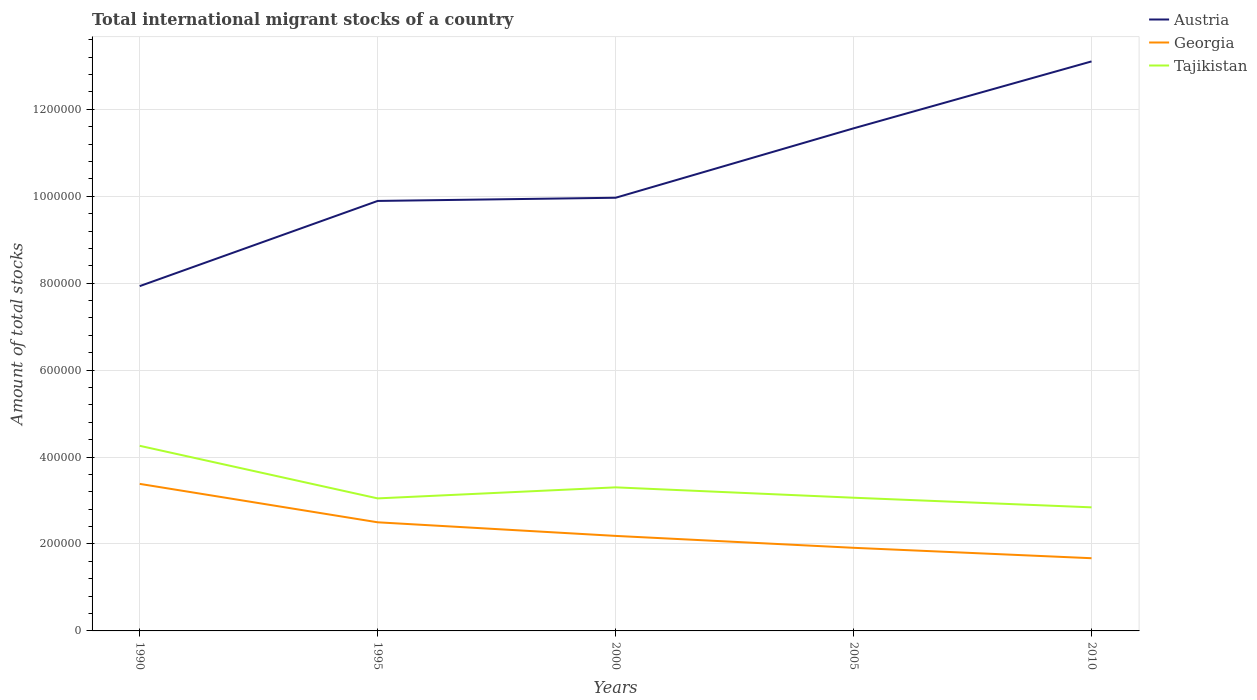Does the line corresponding to Georgia intersect with the line corresponding to Tajikistan?
Provide a short and direct response. No. Is the number of lines equal to the number of legend labels?
Offer a very short reply. Yes. Across all years, what is the maximum amount of total stocks in in Austria?
Keep it short and to the point. 7.93e+05. In which year was the amount of total stocks in in Tajikistan maximum?
Provide a short and direct response. 2010. What is the total amount of total stocks in in Tajikistan in the graph?
Keep it short and to the point. 2.06e+04. What is the difference between the highest and the second highest amount of total stocks in in Georgia?
Give a very brief answer. 1.71e+05. How many lines are there?
Provide a succinct answer. 3. What is the difference between two consecutive major ticks on the Y-axis?
Provide a short and direct response. 2.00e+05. Does the graph contain any zero values?
Provide a short and direct response. No. Where does the legend appear in the graph?
Give a very brief answer. Top right. How are the legend labels stacked?
Your answer should be very brief. Vertical. What is the title of the graph?
Provide a short and direct response. Total international migrant stocks of a country. What is the label or title of the X-axis?
Provide a succinct answer. Years. What is the label or title of the Y-axis?
Keep it short and to the point. Amount of total stocks. What is the Amount of total stocks of Austria in 1990?
Give a very brief answer. 7.93e+05. What is the Amount of total stocks of Georgia in 1990?
Make the answer very short. 3.38e+05. What is the Amount of total stocks in Tajikistan in 1990?
Give a very brief answer. 4.26e+05. What is the Amount of total stocks of Austria in 1995?
Ensure brevity in your answer.  9.89e+05. What is the Amount of total stocks in Georgia in 1995?
Ensure brevity in your answer.  2.50e+05. What is the Amount of total stocks of Tajikistan in 1995?
Your answer should be compact. 3.05e+05. What is the Amount of total stocks of Austria in 2000?
Ensure brevity in your answer.  9.97e+05. What is the Amount of total stocks in Georgia in 2000?
Provide a succinct answer. 2.19e+05. What is the Amount of total stocks in Tajikistan in 2000?
Keep it short and to the point. 3.30e+05. What is the Amount of total stocks of Austria in 2005?
Provide a short and direct response. 1.16e+06. What is the Amount of total stocks in Georgia in 2005?
Offer a very short reply. 1.91e+05. What is the Amount of total stocks in Tajikistan in 2005?
Keep it short and to the point. 3.06e+05. What is the Amount of total stocks in Austria in 2010?
Make the answer very short. 1.31e+06. What is the Amount of total stocks in Georgia in 2010?
Give a very brief answer. 1.67e+05. What is the Amount of total stocks of Tajikistan in 2010?
Offer a terse response. 2.84e+05. Across all years, what is the maximum Amount of total stocks in Austria?
Your response must be concise. 1.31e+06. Across all years, what is the maximum Amount of total stocks in Georgia?
Offer a very short reply. 3.38e+05. Across all years, what is the maximum Amount of total stocks in Tajikistan?
Your response must be concise. 4.26e+05. Across all years, what is the minimum Amount of total stocks of Austria?
Offer a terse response. 7.93e+05. Across all years, what is the minimum Amount of total stocks of Georgia?
Your response must be concise. 1.67e+05. Across all years, what is the minimum Amount of total stocks in Tajikistan?
Your answer should be compact. 2.84e+05. What is the total Amount of total stocks of Austria in the graph?
Give a very brief answer. 5.25e+06. What is the total Amount of total stocks of Georgia in the graph?
Offer a terse response. 1.17e+06. What is the total Amount of total stocks of Tajikistan in the graph?
Your answer should be very brief. 1.65e+06. What is the difference between the Amount of total stocks in Austria in 1990 and that in 1995?
Your answer should be compact. -1.96e+05. What is the difference between the Amount of total stocks in Georgia in 1990 and that in 1995?
Keep it short and to the point. 8.84e+04. What is the difference between the Amount of total stocks of Tajikistan in 1990 and that in 1995?
Ensure brevity in your answer.  1.21e+05. What is the difference between the Amount of total stocks in Austria in 1990 and that in 2000?
Offer a very short reply. -2.03e+05. What is the difference between the Amount of total stocks of Georgia in 1990 and that in 2000?
Provide a short and direct response. 1.20e+05. What is the difference between the Amount of total stocks of Tajikistan in 1990 and that in 2000?
Keep it short and to the point. 9.56e+04. What is the difference between the Amount of total stocks of Austria in 1990 and that in 2005?
Ensure brevity in your answer.  -3.63e+05. What is the difference between the Amount of total stocks in Georgia in 1990 and that in 2005?
Your response must be concise. 1.47e+05. What is the difference between the Amount of total stocks of Tajikistan in 1990 and that in 2005?
Offer a terse response. 1.19e+05. What is the difference between the Amount of total stocks in Austria in 1990 and that in 2010?
Ensure brevity in your answer.  -5.17e+05. What is the difference between the Amount of total stocks in Georgia in 1990 and that in 2010?
Provide a succinct answer. 1.71e+05. What is the difference between the Amount of total stocks of Tajikistan in 1990 and that in 2010?
Offer a terse response. 1.42e+05. What is the difference between the Amount of total stocks of Austria in 1995 and that in 2000?
Your answer should be compact. -7314. What is the difference between the Amount of total stocks of Georgia in 1995 and that in 2000?
Give a very brief answer. 3.13e+04. What is the difference between the Amount of total stocks of Tajikistan in 1995 and that in 2000?
Ensure brevity in your answer.  -2.54e+04. What is the difference between the Amount of total stocks in Austria in 1995 and that in 2005?
Keep it short and to the point. -1.67e+05. What is the difference between the Amount of total stocks in Georgia in 1995 and that in 2005?
Your response must be concise. 5.87e+04. What is the difference between the Amount of total stocks of Tajikistan in 1995 and that in 2005?
Your response must be concise. -1533. What is the difference between the Amount of total stocks of Austria in 1995 and that in 2010?
Provide a succinct answer. -3.21e+05. What is the difference between the Amount of total stocks in Georgia in 1995 and that in 2010?
Offer a very short reply. 8.26e+04. What is the difference between the Amount of total stocks of Tajikistan in 1995 and that in 2010?
Provide a short and direct response. 2.06e+04. What is the difference between the Amount of total stocks of Austria in 2000 and that in 2005?
Offer a terse response. -1.60e+05. What is the difference between the Amount of total stocks in Georgia in 2000 and that in 2005?
Provide a succinct answer. 2.74e+04. What is the difference between the Amount of total stocks in Tajikistan in 2000 and that in 2005?
Ensure brevity in your answer.  2.39e+04. What is the difference between the Amount of total stocks in Austria in 2000 and that in 2010?
Your answer should be compact. -3.14e+05. What is the difference between the Amount of total stocks of Georgia in 2000 and that in 2010?
Your response must be concise. 5.13e+04. What is the difference between the Amount of total stocks in Tajikistan in 2000 and that in 2010?
Your answer should be very brief. 4.60e+04. What is the difference between the Amount of total stocks in Austria in 2005 and that in 2010?
Your response must be concise. -1.54e+05. What is the difference between the Amount of total stocks in Georgia in 2005 and that in 2010?
Provide a short and direct response. 2.40e+04. What is the difference between the Amount of total stocks of Tajikistan in 2005 and that in 2010?
Make the answer very short. 2.21e+04. What is the difference between the Amount of total stocks of Austria in 1990 and the Amount of total stocks of Georgia in 1995?
Ensure brevity in your answer.  5.43e+05. What is the difference between the Amount of total stocks of Austria in 1990 and the Amount of total stocks of Tajikistan in 1995?
Make the answer very short. 4.88e+05. What is the difference between the Amount of total stocks in Georgia in 1990 and the Amount of total stocks in Tajikistan in 1995?
Offer a very short reply. 3.34e+04. What is the difference between the Amount of total stocks in Austria in 1990 and the Amount of total stocks in Georgia in 2000?
Give a very brief answer. 5.75e+05. What is the difference between the Amount of total stocks in Austria in 1990 and the Amount of total stocks in Tajikistan in 2000?
Provide a short and direct response. 4.63e+05. What is the difference between the Amount of total stocks in Georgia in 1990 and the Amount of total stocks in Tajikistan in 2000?
Provide a short and direct response. 8000. What is the difference between the Amount of total stocks in Austria in 1990 and the Amount of total stocks in Georgia in 2005?
Give a very brief answer. 6.02e+05. What is the difference between the Amount of total stocks in Austria in 1990 and the Amount of total stocks in Tajikistan in 2005?
Your answer should be compact. 4.87e+05. What is the difference between the Amount of total stocks in Georgia in 1990 and the Amount of total stocks in Tajikistan in 2005?
Make the answer very short. 3.19e+04. What is the difference between the Amount of total stocks in Austria in 1990 and the Amount of total stocks in Georgia in 2010?
Your answer should be compact. 6.26e+05. What is the difference between the Amount of total stocks of Austria in 1990 and the Amount of total stocks of Tajikistan in 2010?
Provide a short and direct response. 5.09e+05. What is the difference between the Amount of total stocks in Georgia in 1990 and the Amount of total stocks in Tajikistan in 2010?
Your answer should be very brief. 5.40e+04. What is the difference between the Amount of total stocks of Austria in 1995 and the Amount of total stocks of Georgia in 2000?
Provide a short and direct response. 7.71e+05. What is the difference between the Amount of total stocks of Austria in 1995 and the Amount of total stocks of Tajikistan in 2000?
Ensure brevity in your answer.  6.59e+05. What is the difference between the Amount of total stocks in Georgia in 1995 and the Amount of total stocks in Tajikistan in 2000?
Provide a succinct answer. -8.04e+04. What is the difference between the Amount of total stocks in Austria in 1995 and the Amount of total stocks in Georgia in 2005?
Provide a succinct answer. 7.98e+05. What is the difference between the Amount of total stocks of Austria in 1995 and the Amount of total stocks of Tajikistan in 2005?
Give a very brief answer. 6.83e+05. What is the difference between the Amount of total stocks of Georgia in 1995 and the Amount of total stocks of Tajikistan in 2005?
Keep it short and to the point. -5.65e+04. What is the difference between the Amount of total stocks in Austria in 1995 and the Amount of total stocks in Georgia in 2010?
Provide a succinct answer. 8.22e+05. What is the difference between the Amount of total stocks of Austria in 1995 and the Amount of total stocks of Tajikistan in 2010?
Provide a short and direct response. 7.05e+05. What is the difference between the Amount of total stocks of Georgia in 1995 and the Amount of total stocks of Tajikistan in 2010?
Offer a very short reply. -3.44e+04. What is the difference between the Amount of total stocks of Austria in 2000 and the Amount of total stocks of Georgia in 2005?
Provide a short and direct response. 8.05e+05. What is the difference between the Amount of total stocks in Austria in 2000 and the Amount of total stocks in Tajikistan in 2005?
Your answer should be compact. 6.90e+05. What is the difference between the Amount of total stocks of Georgia in 2000 and the Amount of total stocks of Tajikistan in 2005?
Your answer should be compact. -8.78e+04. What is the difference between the Amount of total stocks of Austria in 2000 and the Amount of total stocks of Georgia in 2010?
Give a very brief answer. 8.29e+05. What is the difference between the Amount of total stocks of Austria in 2000 and the Amount of total stocks of Tajikistan in 2010?
Offer a terse response. 7.12e+05. What is the difference between the Amount of total stocks in Georgia in 2000 and the Amount of total stocks in Tajikistan in 2010?
Your response must be concise. -6.57e+04. What is the difference between the Amount of total stocks in Austria in 2005 and the Amount of total stocks in Georgia in 2010?
Provide a short and direct response. 9.89e+05. What is the difference between the Amount of total stocks of Austria in 2005 and the Amount of total stocks of Tajikistan in 2010?
Make the answer very short. 8.72e+05. What is the difference between the Amount of total stocks in Georgia in 2005 and the Amount of total stocks in Tajikistan in 2010?
Provide a short and direct response. -9.31e+04. What is the average Amount of total stocks in Austria per year?
Provide a short and direct response. 1.05e+06. What is the average Amount of total stocks in Georgia per year?
Your answer should be compact. 2.33e+05. What is the average Amount of total stocks of Tajikistan per year?
Offer a very short reply. 3.30e+05. In the year 1990, what is the difference between the Amount of total stocks of Austria and Amount of total stocks of Georgia?
Give a very brief answer. 4.55e+05. In the year 1990, what is the difference between the Amount of total stocks in Austria and Amount of total stocks in Tajikistan?
Your response must be concise. 3.67e+05. In the year 1990, what is the difference between the Amount of total stocks in Georgia and Amount of total stocks in Tajikistan?
Offer a terse response. -8.76e+04. In the year 1995, what is the difference between the Amount of total stocks of Austria and Amount of total stocks of Georgia?
Provide a short and direct response. 7.39e+05. In the year 1995, what is the difference between the Amount of total stocks of Austria and Amount of total stocks of Tajikistan?
Ensure brevity in your answer.  6.84e+05. In the year 1995, what is the difference between the Amount of total stocks of Georgia and Amount of total stocks of Tajikistan?
Your answer should be very brief. -5.50e+04. In the year 2000, what is the difference between the Amount of total stocks of Austria and Amount of total stocks of Georgia?
Your response must be concise. 7.78e+05. In the year 2000, what is the difference between the Amount of total stocks in Austria and Amount of total stocks in Tajikistan?
Offer a terse response. 6.66e+05. In the year 2000, what is the difference between the Amount of total stocks of Georgia and Amount of total stocks of Tajikistan?
Your answer should be compact. -1.12e+05. In the year 2005, what is the difference between the Amount of total stocks of Austria and Amount of total stocks of Georgia?
Make the answer very short. 9.65e+05. In the year 2005, what is the difference between the Amount of total stocks in Austria and Amount of total stocks in Tajikistan?
Your answer should be compact. 8.50e+05. In the year 2005, what is the difference between the Amount of total stocks in Georgia and Amount of total stocks in Tajikistan?
Make the answer very short. -1.15e+05. In the year 2010, what is the difference between the Amount of total stocks of Austria and Amount of total stocks of Georgia?
Offer a very short reply. 1.14e+06. In the year 2010, what is the difference between the Amount of total stocks of Austria and Amount of total stocks of Tajikistan?
Ensure brevity in your answer.  1.03e+06. In the year 2010, what is the difference between the Amount of total stocks of Georgia and Amount of total stocks of Tajikistan?
Keep it short and to the point. -1.17e+05. What is the ratio of the Amount of total stocks in Austria in 1990 to that in 1995?
Offer a very short reply. 0.8. What is the ratio of the Amount of total stocks in Georgia in 1990 to that in 1995?
Make the answer very short. 1.35. What is the ratio of the Amount of total stocks in Tajikistan in 1990 to that in 1995?
Provide a succinct answer. 1.4. What is the ratio of the Amount of total stocks of Austria in 1990 to that in 2000?
Offer a very short reply. 0.8. What is the ratio of the Amount of total stocks in Georgia in 1990 to that in 2000?
Your answer should be very brief. 1.55. What is the ratio of the Amount of total stocks of Tajikistan in 1990 to that in 2000?
Your answer should be very brief. 1.29. What is the ratio of the Amount of total stocks of Austria in 1990 to that in 2005?
Make the answer very short. 0.69. What is the ratio of the Amount of total stocks of Georgia in 1990 to that in 2005?
Offer a terse response. 1.77. What is the ratio of the Amount of total stocks of Tajikistan in 1990 to that in 2005?
Your answer should be very brief. 1.39. What is the ratio of the Amount of total stocks in Austria in 1990 to that in 2010?
Ensure brevity in your answer.  0.61. What is the ratio of the Amount of total stocks in Georgia in 1990 to that in 2010?
Offer a terse response. 2.02. What is the ratio of the Amount of total stocks of Tajikistan in 1990 to that in 2010?
Ensure brevity in your answer.  1.5. What is the ratio of the Amount of total stocks of Austria in 1995 to that in 2000?
Offer a terse response. 0.99. What is the ratio of the Amount of total stocks of Georgia in 1995 to that in 2000?
Give a very brief answer. 1.14. What is the ratio of the Amount of total stocks of Austria in 1995 to that in 2005?
Make the answer very short. 0.86. What is the ratio of the Amount of total stocks of Georgia in 1995 to that in 2005?
Keep it short and to the point. 1.31. What is the ratio of the Amount of total stocks in Tajikistan in 1995 to that in 2005?
Provide a short and direct response. 0.99. What is the ratio of the Amount of total stocks in Austria in 1995 to that in 2010?
Keep it short and to the point. 0.76. What is the ratio of the Amount of total stocks of Georgia in 1995 to that in 2010?
Provide a short and direct response. 1.49. What is the ratio of the Amount of total stocks in Tajikistan in 1995 to that in 2010?
Offer a terse response. 1.07. What is the ratio of the Amount of total stocks in Austria in 2000 to that in 2005?
Provide a succinct answer. 0.86. What is the ratio of the Amount of total stocks in Georgia in 2000 to that in 2005?
Offer a very short reply. 1.14. What is the ratio of the Amount of total stocks in Tajikistan in 2000 to that in 2005?
Make the answer very short. 1.08. What is the ratio of the Amount of total stocks of Austria in 2000 to that in 2010?
Your answer should be very brief. 0.76. What is the ratio of the Amount of total stocks in Georgia in 2000 to that in 2010?
Offer a very short reply. 1.31. What is the ratio of the Amount of total stocks in Tajikistan in 2000 to that in 2010?
Make the answer very short. 1.16. What is the ratio of the Amount of total stocks of Austria in 2005 to that in 2010?
Provide a short and direct response. 0.88. What is the ratio of the Amount of total stocks in Georgia in 2005 to that in 2010?
Your response must be concise. 1.14. What is the ratio of the Amount of total stocks in Tajikistan in 2005 to that in 2010?
Keep it short and to the point. 1.08. What is the difference between the highest and the second highest Amount of total stocks of Austria?
Offer a terse response. 1.54e+05. What is the difference between the highest and the second highest Amount of total stocks of Georgia?
Your answer should be very brief. 8.84e+04. What is the difference between the highest and the second highest Amount of total stocks in Tajikistan?
Make the answer very short. 9.56e+04. What is the difference between the highest and the lowest Amount of total stocks of Austria?
Offer a terse response. 5.17e+05. What is the difference between the highest and the lowest Amount of total stocks in Georgia?
Your response must be concise. 1.71e+05. What is the difference between the highest and the lowest Amount of total stocks in Tajikistan?
Provide a short and direct response. 1.42e+05. 